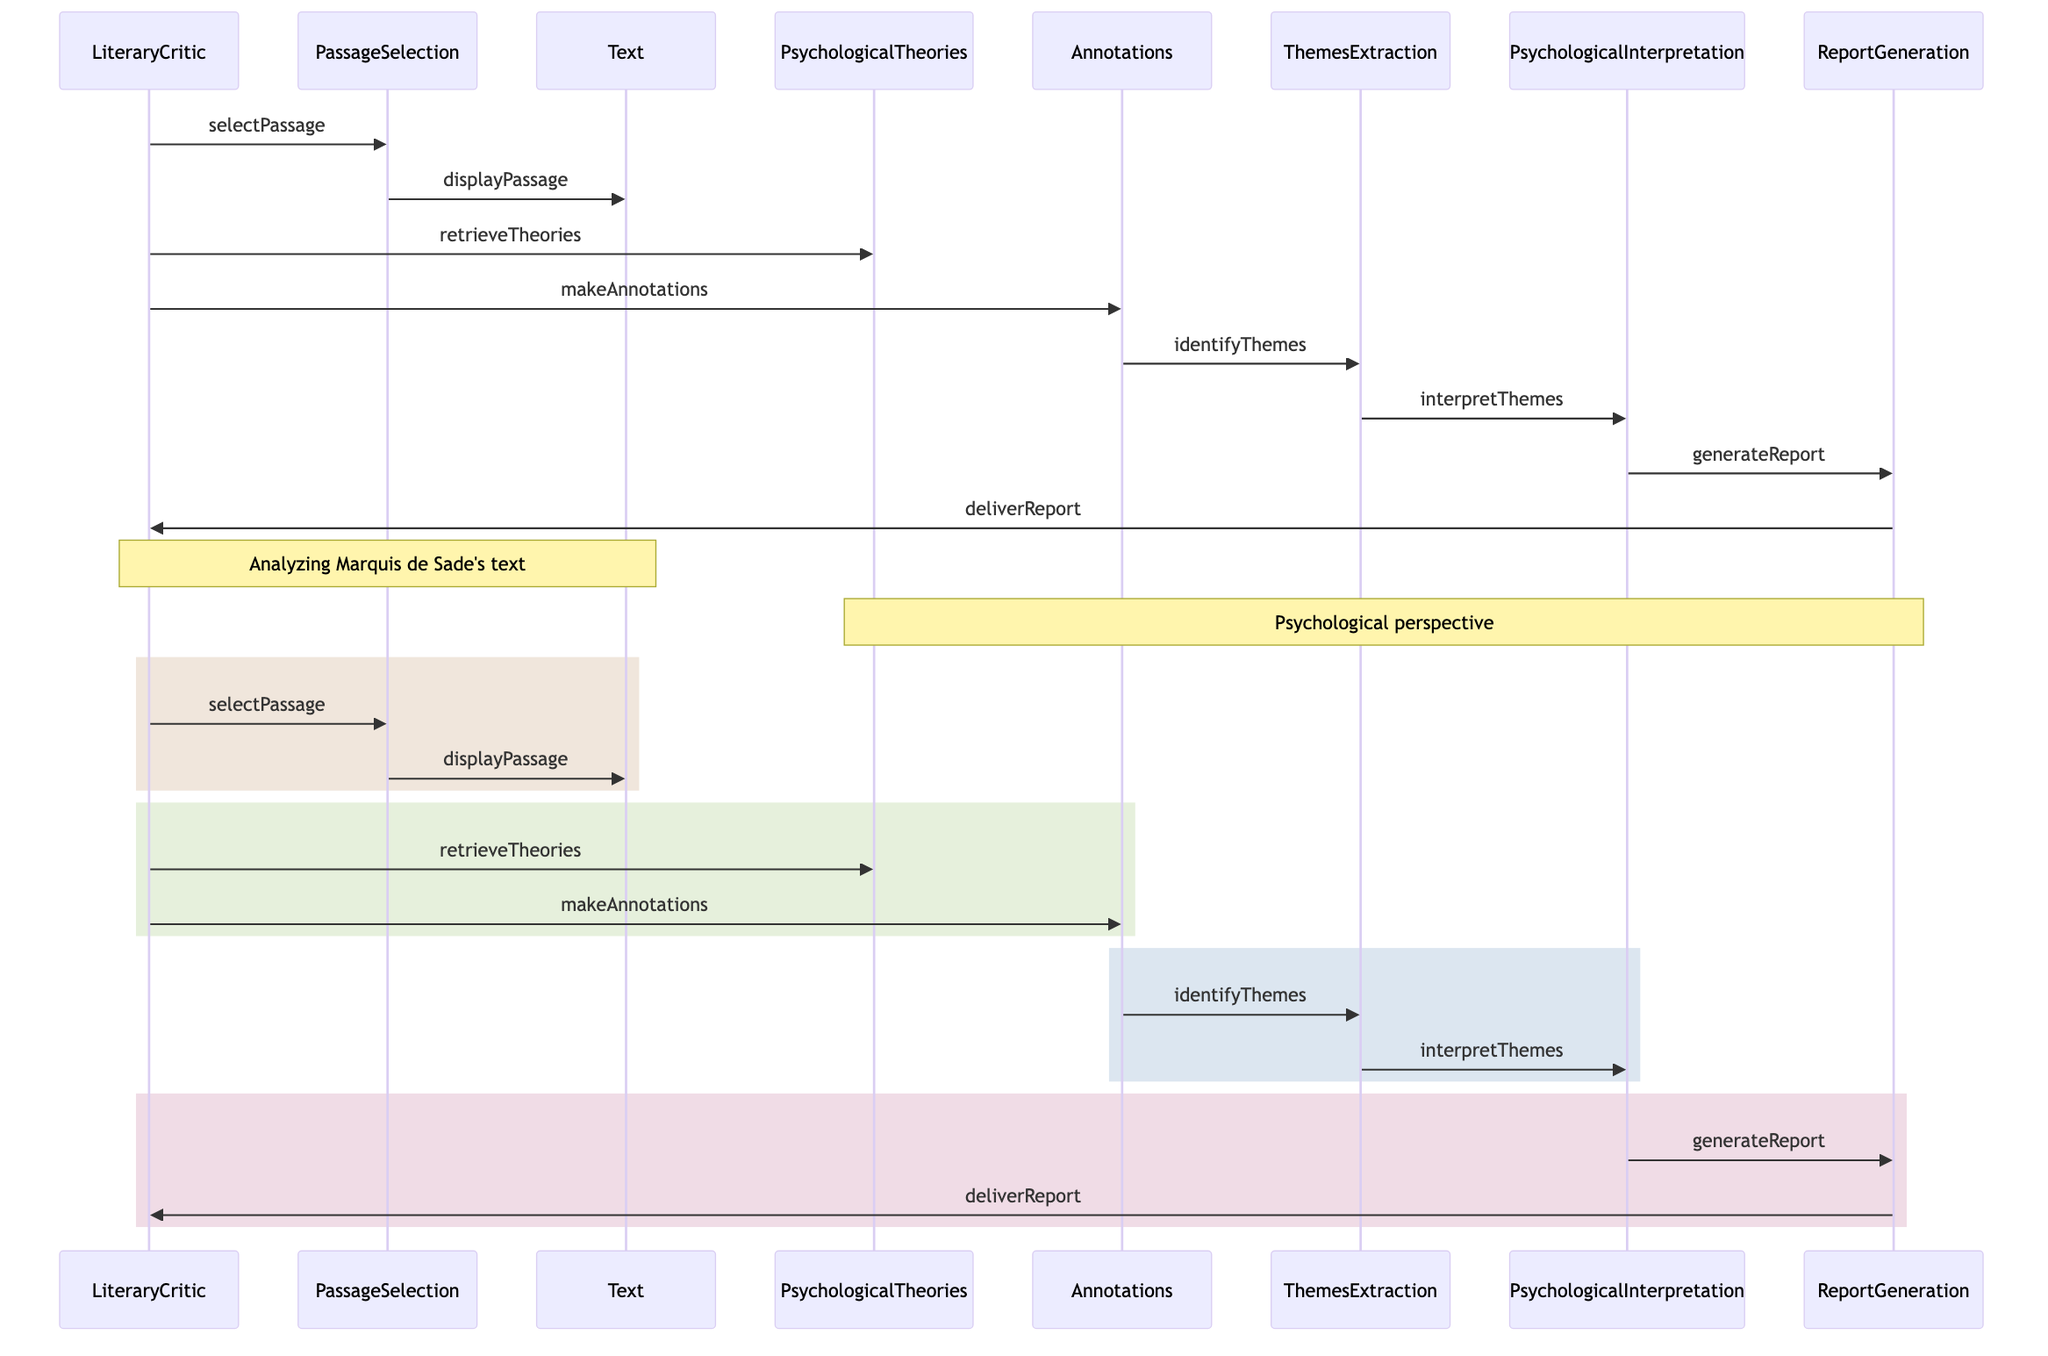What is the first operation performed by the LiteraryCritic? The first operation listed in the diagram shows the LiteraryCritic selecting a passage, represented by the interaction 'selectPassage' with the PassageSelection object.
Answer: selectPassage How many actors are present in the diagram? The diagram includes two actors: LiteraryCritic and Text. Therefore, when counting these unique entities referred to as actors, the answer is two.
Answer: 2 What is the last operation performed in the sequence? The final operation is represented by the interaction 'deliverReport', where the ReportGeneration delivers the completed report back to the LiteraryCritic.
Answer: deliverReport Which object is responsible for retrieving psychological theories? The LiteraryCritic interacts with the PsychologicalTheories object using the 'retrieveTheories' operation, indicating that this object is where the theories are sourced from.
Answer: PsychologicalTheories What is the purpose of Annotations in the analysis process? Annotations serve the crucial function of allowing the LiteraryCritic to make critical notes and observations on the selected passage, which aids subsequent analysis steps.
Answer: makeAnnotations How many distinct stages are depicted in the diagram? The diagram can be segmented into four distinct stages that are clearly outlined by the colored rectangles: selection, retrieval, theme identification, and report generation.
Answer: 4 What follows the identification of themes? After identifying themes through Annotations, the next operation in the flow is interpreting these themes, which is handled by the PsychologicalInterpretation object.
Answer: interpretThemes Which object is directly linked to the delivery of the report? The ReportGeneration object creates the report and is directly connected to the deliverReport operation that delivers it back to the LiteraryCritic.
Answer: ReportGeneration 